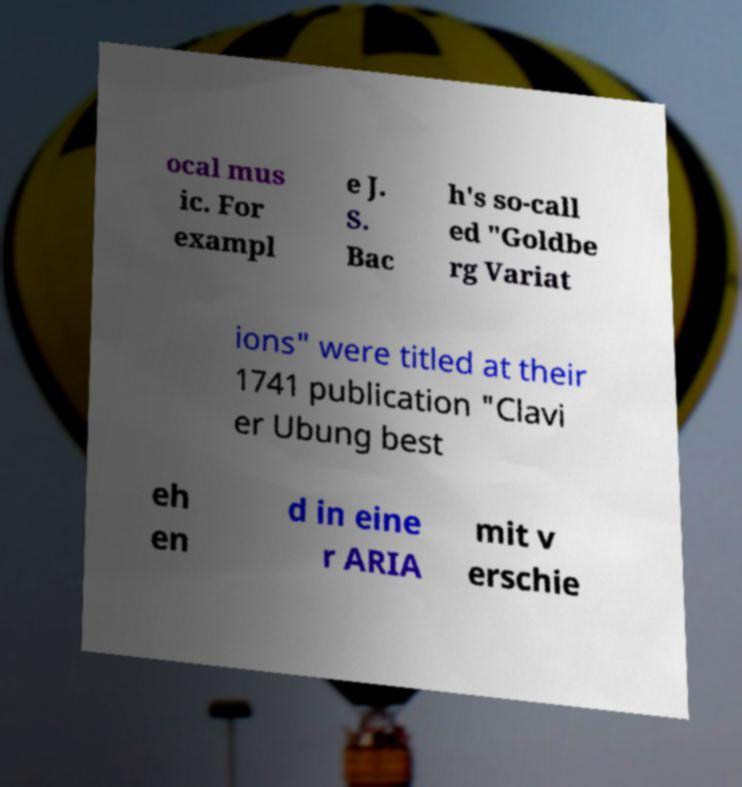Please read and relay the text visible in this image. What does it say? ocal mus ic. For exampl e J. S. Bac h's so-call ed "Goldbe rg Variat ions" were titled at their 1741 publication "Clavi er Ubung best eh en d in eine r ARIA mit v erschie 